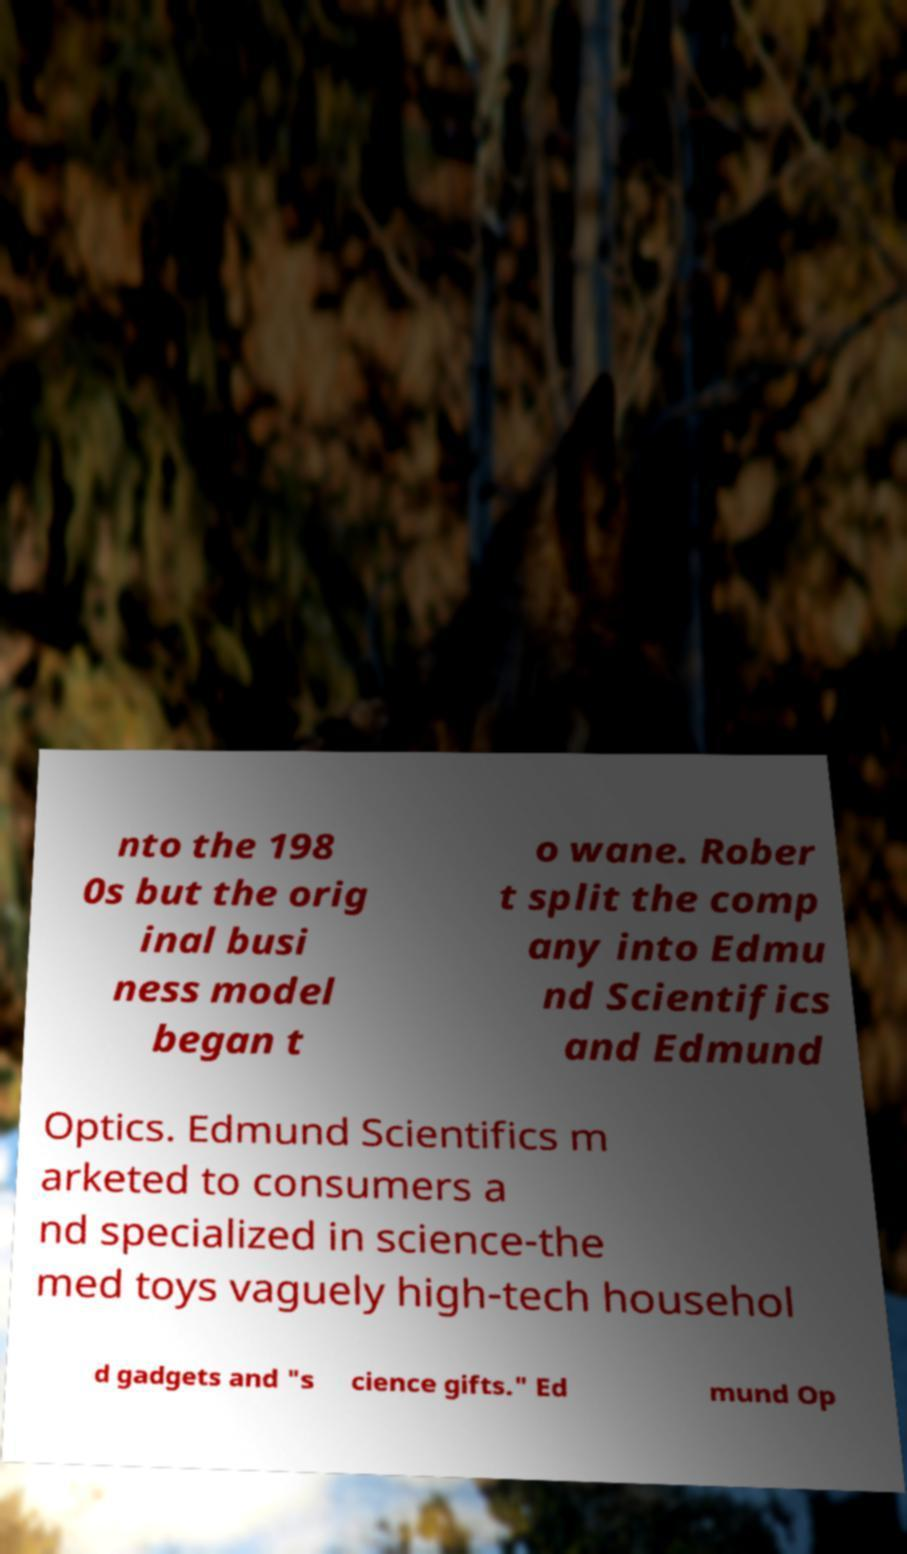I need the written content from this picture converted into text. Can you do that? nto the 198 0s but the orig inal busi ness model began t o wane. Rober t split the comp any into Edmu nd Scientifics and Edmund Optics. Edmund Scientifics m arketed to consumers a nd specialized in science-the med toys vaguely high-tech househol d gadgets and "s cience gifts." Ed mund Op 